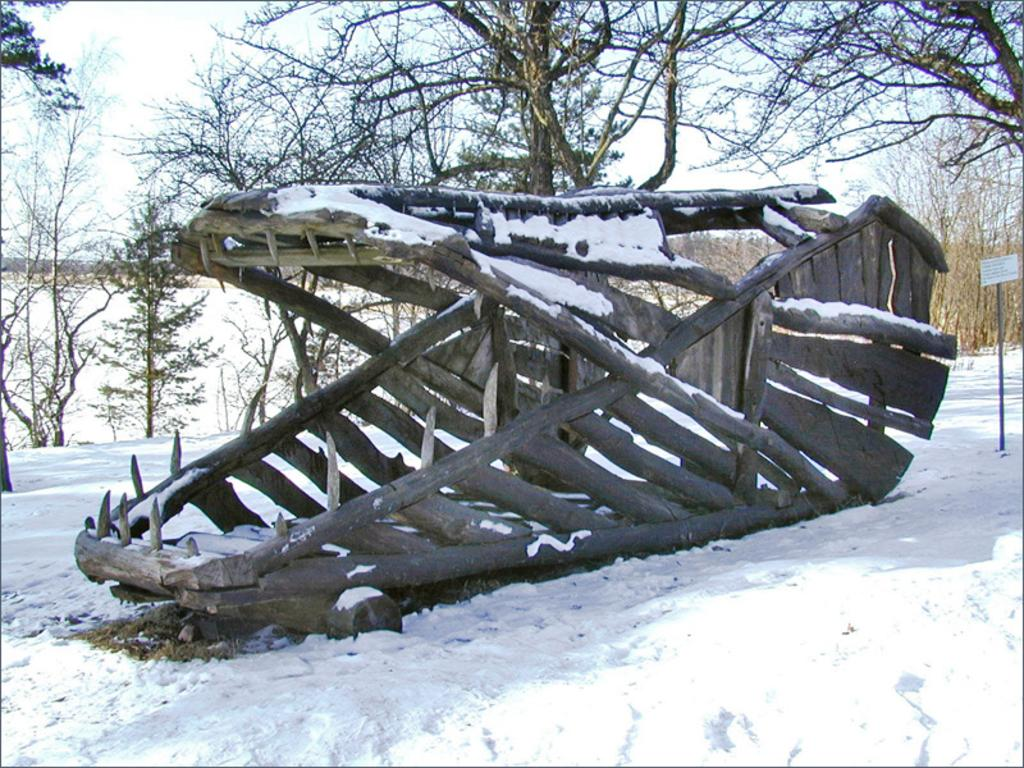What type of weather condition is depicted at the bottom of the image? There is snow at the bottom of the image. What structure is located in the middle of the image? There is a wooden frame in the middle of the image. What type of vegetation can be seen in the background of the image? There are trees in the background of the image. What is visible at the top of the image? The sky is visible at the top of the image. What type of fowl can be seen flying in the image? There is no fowl present in the image. What mode of transport is visible in the image? There is no transport visible in the image. 